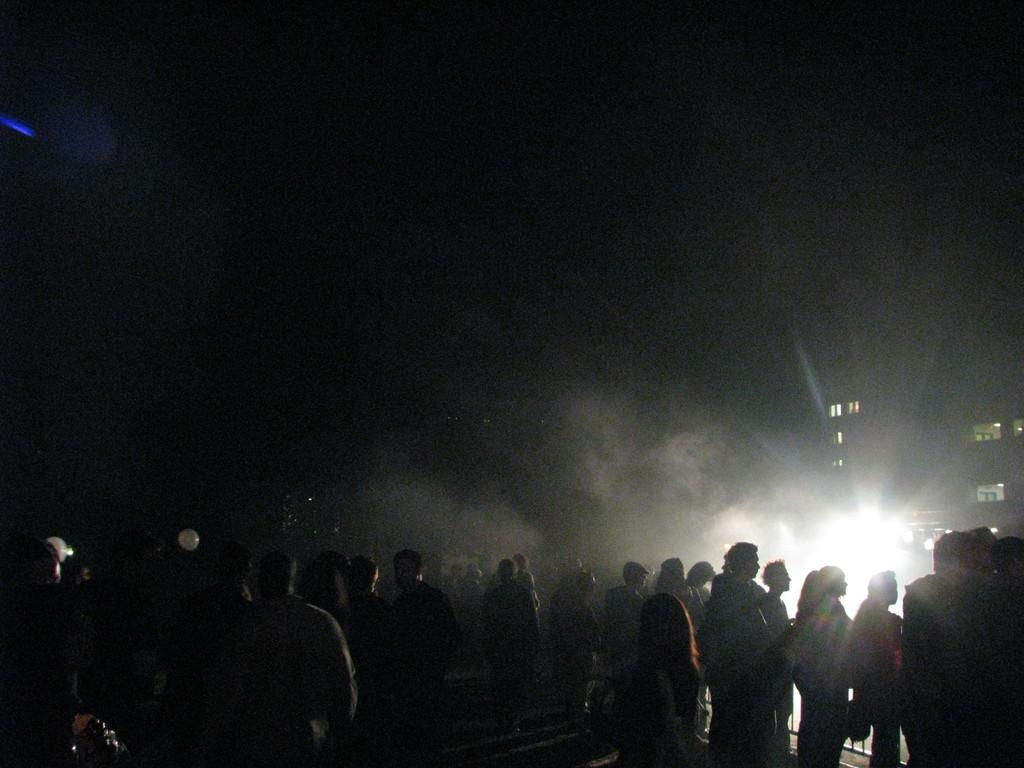Who or what is present in the image? There are people in the image. What can be seen illuminating the scene? The image contains lights. What type of structures are visible in the image? There are buildings in the image. Can you describe the overall lighting condition of the image? The image appears to be slightly dark. What type of produce can be seen growing on the buildings in the image? There is no produce visible on the buildings in the image; the image only shows people, lights, and buildings. 